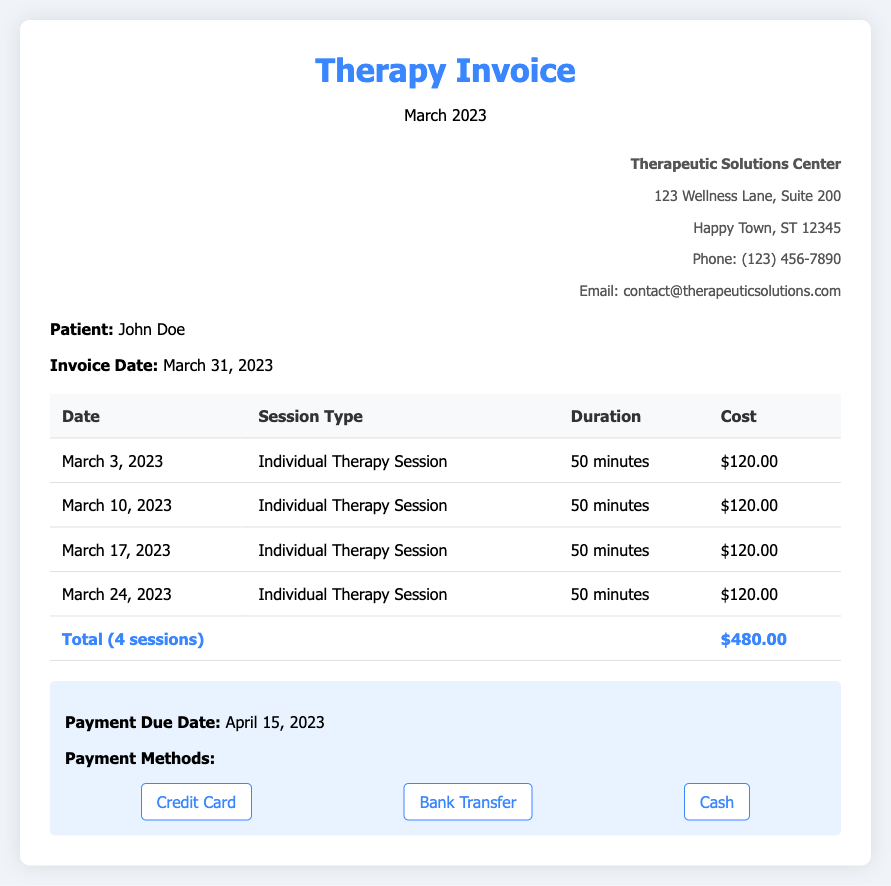What is the total cost of the therapy sessions? The total cost is calculated by summing the costs of all individual therapy sessions listed in the document. The invoice specifies a total of $480.00 for 4 sessions.
Answer: $480.00 Who is the patient listed in the invoice? The document provides the name of the patient in the patient info section, which is John Doe.
Answer: John Doe What date is the invoice dated? The invoice date is mentioned in the patient info section, specifically stating March 31, 2023.
Answer: March 31, 2023 How many therapy sessions were held in March? The document lists the individual therapy sessions, showing that there were 4 sessions held during March.
Answer: 4 sessions What is the maximum number of payment methods listed? The document includes three payment methods in the payment info section, highlighting the options available to the patient.
Answer: 3 methods What is the cost of a single therapy session? Each of the therapy sessions listed in the document has a consistent cost of $120.00.
Answer: $120.00 When is the payment due? The payment due date is explicitly stated in the payment info section as April 15, 2023.
Answer: April 15, 2023 Where is the Therapeutic Solutions Center located? The address of the Therapeutic Solutions Center is given in the provider info section as 123 Wellness Lane, Suite 200, Happy Town, ST 12345.
Answer: 123 Wellness Lane, Suite 200 How long is each therapy session? Each individual therapy session listed in the document has a duration of 50 minutes as stated in the session details.
Answer: 50 minutes 